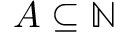Convert formula to latex. <formula><loc_0><loc_0><loc_500><loc_500>A \subseteq \mathbb { N }</formula> 